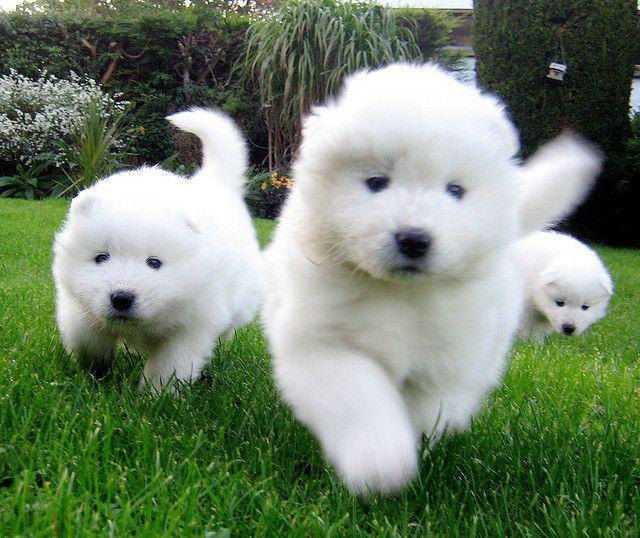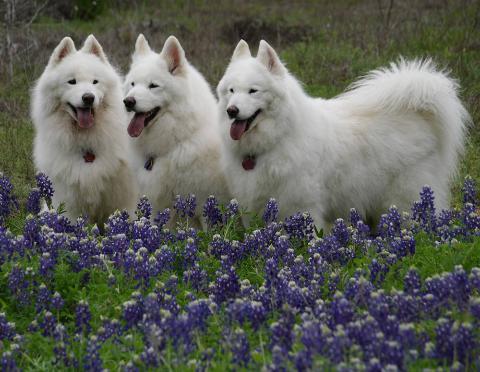The first image is the image on the left, the second image is the image on the right. Examine the images to the left and right. Is the description "The left image shows a woman next to no less than one white dog" accurate? Answer yes or no. No. 